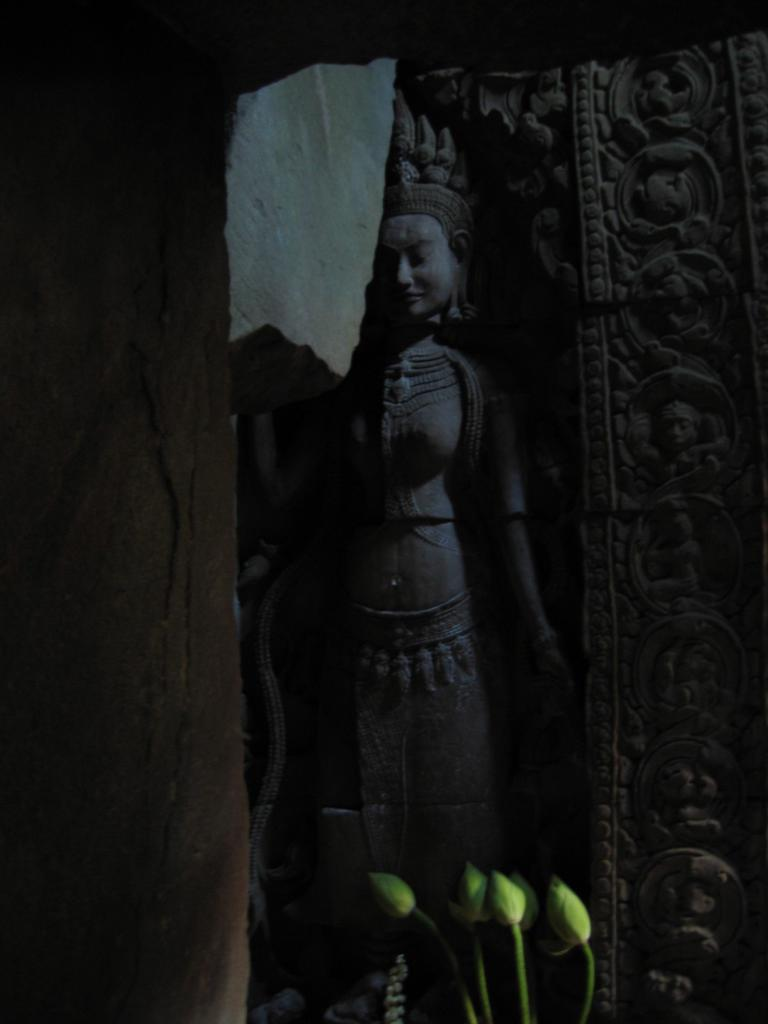What is the main subject of the image? The main subject of the image is a sculpture. What other objects or elements can be seen in the image? There are lotus buds in the image. How much does the pet value the stitch in the image? There is no pet or stitch present in the image. 